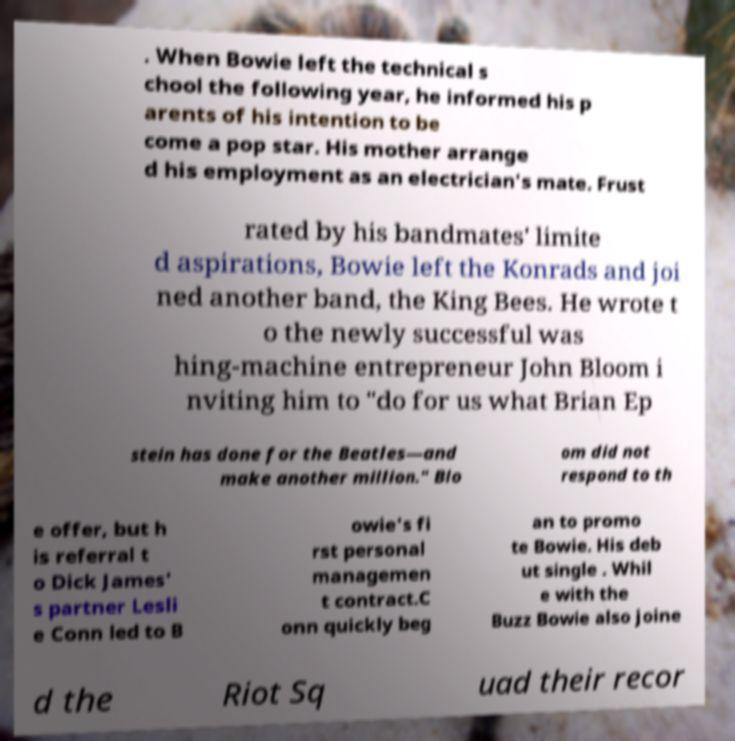For documentation purposes, I need the text within this image transcribed. Could you provide that? . When Bowie left the technical s chool the following year, he informed his p arents of his intention to be come a pop star. His mother arrange d his employment as an electrician's mate. Frust rated by his bandmates' limite d aspirations, Bowie left the Konrads and joi ned another band, the King Bees. He wrote t o the newly successful was hing-machine entrepreneur John Bloom i nviting him to "do for us what Brian Ep stein has done for the Beatles—and make another million." Blo om did not respond to th e offer, but h is referral t o Dick James' s partner Lesli e Conn led to B owie's fi rst personal managemen t contract.C onn quickly beg an to promo te Bowie. His deb ut single . Whil e with the Buzz Bowie also joine d the Riot Sq uad their recor 